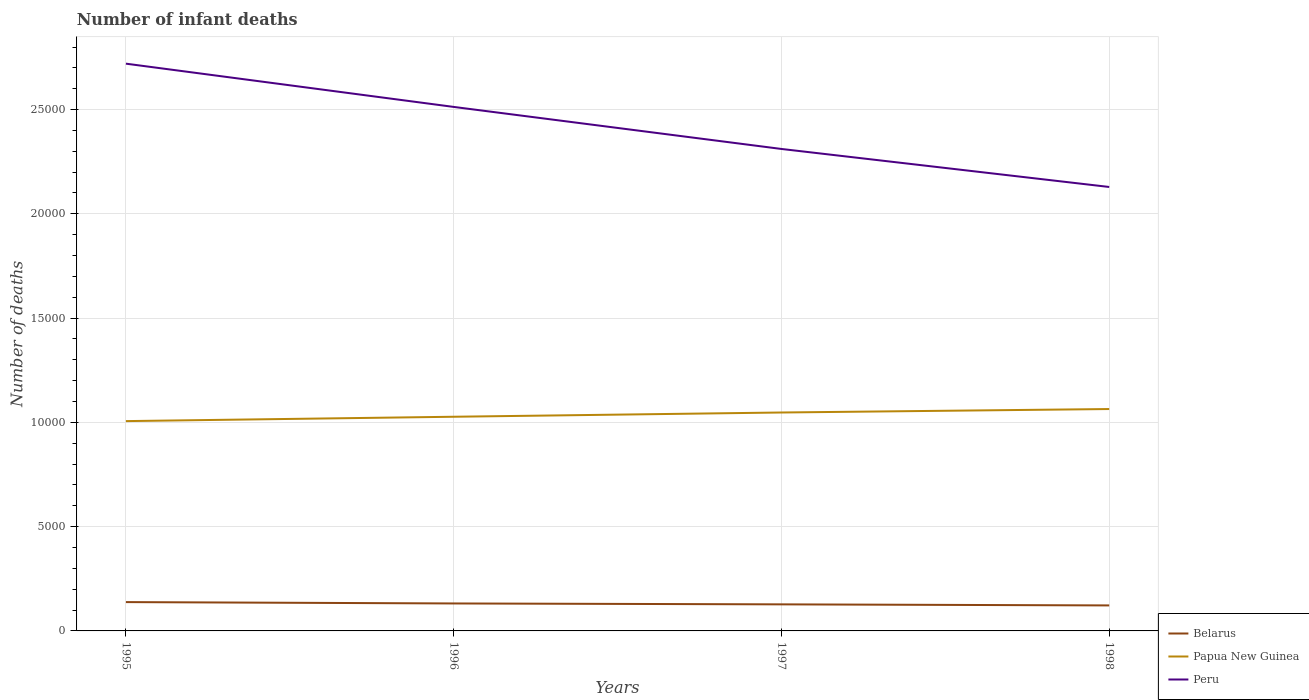How many different coloured lines are there?
Ensure brevity in your answer.  3. Across all years, what is the maximum number of infant deaths in Peru?
Provide a short and direct response. 2.13e+04. In which year was the number of infant deaths in Peru maximum?
Ensure brevity in your answer.  1998. What is the total number of infant deaths in Peru in the graph?
Make the answer very short. 4090. What is the difference between the highest and the second highest number of infant deaths in Belarus?
Your answer should be compact. 159. How many lines are there?
Keep it short and to the point. 3. Are the values on the major ticks of Y-axis written in scientific E-notation?
Your response must be concise. No. Does the graph contain any zero values?
Ensure brevity in your answer.  No. Does the graph contain grids?
Make the answer very short. Yes. Where does the legend appear in the graph?
Offer a terse response. Bottom right. How many legend labels are there?
Make the answer very short. 3. How are the legend labels stacked?
Provide a short and direct response. Vertical. What is the title of the graph?
Your answer should be compact. Number of infant deaths. What is the label or title of the Y-axis?
Your response must be concise. Number of deaths. What is the Number of deaths of Belarus in 1995?
Give a very brief answer. 1382. What is the Number of deaths of Papua New Guinea in 1995?
Offer a very short reply. 1.01e+04. What is the Number of deaths of Peru in 1995?
Provide a short and direct response. 2.72e+04. What is the Number of deaths of Belarus in 1996?
Offer a terse response. 1317. What is the Number of deaths in Papua New Guinea in 1996?
Your answer should be very brief. 1.03e+04. What is the Number of deaths of Peru in 1996?
Provide a succinct answer. 2.51e+04. What is the Number of deaths of Belarus in 1997?
Offer a very short reply. 1274. What is the Number of deaths of Papua New Guinea in 1997?
Provide a succinct answer. 1.05e+04. What is the Number of deaths of Peru in 1997?
Make the answer very short. 2.31e+04. What is the Number of deaths of Belarus in 1998?
Keep it short and to the point. 1223. What is the Number of deaths of Papua New Guinea in 1998?
Offer a terse response. 1.06e+04. What is the Number of deaths in Peru in 1998?
Your answer should be compact. 2.13e+04. Across all years, what is the maximum Number of deaths in Belarus?
Give a very brief answer. 1382. Across all years, what is the maximum Number of deaths in Papua New Guinea?
Make the answer very short. 1.06e+04. Across all years, what is the maximum Number of deaths in Peru?
Make the answer very short. 2.72e+04. Across all years, what is the minimum Number of deaths in Belarus?
Offer a terse response. 1223. Across all years, what is the minimum Number of deaths of Papua New Guinea?
Provide a succinct answer. 1.01e+04. Across all years, what is the minimum Number of deaths in Peru?
Provide a succinct answer. 2.13e+04. What is the total Number of deaths in Belarus in the graph?
Provide a succinct answer. 5196. What is the total Number of deaths in Papua New Guinea in the graph?
Your answer should be very brief. 4.14e+04. What is the total Number of deaths of Peru in the graph?
Provide a succinct answer. 9.67e+04. What is the difference between the Number of deaths in Belarus in 1995 and that in 1996?
Make the answer very short. 65. What is the difference between the Number of deaths of Papua New Guinea in 1995 and that in 1996?
Your answer should be very brief. -209. What is the difference between the Number of deaths of Peru in 1995 and that in 1996?
Ensure brevity in your answer.  2074. What is the difference between the Number of deaths of Belarus in 1995 and that in 1997?
Keep it short and to the point. 108. What is the difference between the Number of deaths of Papua New Guinea in 1995 and that in 1997?
Your answer should be compact. -413. What is the difference between the Number of deaths of Peru in 1995 and that in 1997?
Your answer should be compact. 4090. What is the difference between the Number of deaths of Belarus in 1995 and that in 1998?
Offer a terse response. 159. What is the difference between the Number of deaths of Papua New Guinea in 1995 and that in 1998?
Offer a very short reply. -579. What is the difference between the Number of deaths in Peru in 1995 and that in 1998?
Make the answer very short. 5913. What is the difference between the Number of deaths in Belarus in 1996 and that in 1997?
Keep it short and to the point. 43. What is the difference between the Number of deaths of Papua New Guinea in 1996 and that in 1997?
Offer a terse response. -204. What is the difference between the Number of deaths of Peru in 1996 and that in 1997?
Your answer should be compact. 2016. What is the difference between the Number of deaths of Belarus in 1996 and that in 1998?
Keep it short and to the point. 94. What is the difference between the Number of deaths of Papua New Guinea in 1996 and that in 1998?
Give a very brief answer. -370. What is the difference between the Number of deaths in Peru in 1996 and that in 1998?
Offer a terse response. 3839. What is the difference between the Number of deaths of Belarus in 1997 and that in 1998?
Make the answer very short. 51. What is the difference between the Number of deaths in Papua New Guinea in 1997 and that in 1998?
Offer a very short reply. -166. What is the difference between the Number of deaths in Peru in 1997 and that in 1998?
Ensure brevity in your answer.  1823. What is the difference between the Number of deaths in Belarus in 1995 and the Number of deaths in Papua New Guinea in 1996?
Ensure brevity in your answer.  -8888. What is the difference between the Number of deaths of Belarus in 1995 and the Number of deaths of Peru in 1996?
Keep it short and to the point. -2.37e+04. What is the difference between the Number of deaths in Papua New Guinea in 1995 and the Number of deaths in Peru in 1996?
Make the answer very short. -1.51e+04. What is the difference between the Number of deaths of Belarus in 1995 and the Number of deaths of Papua New Guinea in 1997?
Ensure brevity in your answer.  -9092. What is the difference between the Number of deaths in Belarus in 1995 and the Number of deaths in Peru in 1997?
Provide a short and direct response. -2.17e+04. What is the difference between the Number of deaths of Papua New Guinea in 1995 and the Number of deaths of Peru in 1997?
Give a very brief answer. -1.30e+04. What is the difference between the Number of deaths of Belarus in 1995 and the Number of deaths of Papua New Guinea in 1998?
Give a very brief answer. -9258. What is the difference between the Number of deaths of Belarus in 1995 and the Number of deaths of Peru in 1998?
Provide a succinct answer. -1.99e+04. What is the difference between the Number of deaths of Papua New Guinea in 1995 and the Number of deaths of Peru in 1998?
Give a very brief answer. -1.12e+04. What is the difference between the Number of deaths of Belarus in 1996 and the Number of deaths of Papua New Guinea in 1997?
Ensure brevity in your answer.  -9157. What is the difference between the Number of deaths in Belarus in 1996 and the Number of deaths in Peru in 1997?
Keep it short and to the point. -2.18e+04. What is the difference between the Number of deaths in Papua New Guinea in 1996 and the Number of deaths in Peru in 1997?
Make the answer very short. -1.28e+04. What is the difference between the Number of deaths of Belarus in 1996 and the Number of deaths of Papua New Guinea in 1998?
Your response must be concise. -9323. What is the difference between the Number of deaths of Belarus in 1996 and the Number of deaths of Peru in 1998?
Offer a very short reply. -2.00e+04. What is the difference between the Number of deaths of Papua New Guinea in 1996 and the Number of deaths of Peru in 1998?
Keep it short and to the point. -1.10e+04. What is the difference between the Number of deaths of Belarus in 1997 and the Number of deaths of Papua New Guinea in 1998?
Keep it short and to the point. -9366. What is the difference between the Number of deaths in Belarus in 1997 and the Number of deaths in Peru in 1998?
Keep it short and to the point. -2.00e+04. What is the difference between the Number of deaths in Papua New Guinea in 1997 and the Number of deaths in Peru in 1998?
Give a very brief answer. -1.08e+04. What is the average Number of deaths in Belarus per year?
Keep it short and to the point. 1299. What is the average Number of deaths in Papua New Guinea per year?
Give a very brief answer. 1.04e+04. What is the average Number of deaths in Peru per year?
Keep it short and to the point. 2.42e+04. In the year 1995, what is the difference between the Number of deaths of Belarus and Number of deaths of Papua New Guinea?
Your answer should be very brief. -8679. In the year 1995, what is the difference between the Number of deaths in Belarus and Number of deaths in Peru?
Provide a succinct answer. -2.58e+04. In the year 1995, what is the difference between the Number of deaths in Papua New Guinea and Number of deaths in Peru?
Keep it short and to the point. -1.71e+04. In the year 1996, what is the difference between the Number of deaths of Belarus and Number of deaths of Papua New Guinea?
Keep it short and to the point. -8953. In the year 1996, what is the difference between the Number of deaths in Belarus and Number of deaths in Peru?
Your response must be concise. -2.38e+04. In the year 1996, what is the difference between the Number of deaths of Papua New Guinea and Number of deaths of Peru?
Make the answer very short. -1.49e+04. In the year 1997, what is the difference between the Number of deaths of Belarus and Number of deaths of Papua New Guinea?
Make the answer very short. -9200. In the year 1997, what is the difference between the Number of deaths in Belarus and Number of deaths in Peru?
Your answer should be compact. -2.18e+04. In the year 1997, what is the difference between the Number of deaths of Papua New Guinea and Number of deaths of Peru?
Make the answer very short. -1.26e+04. In the year 1998, what is the difference between the Number of deaths of Belarus and Number of deaths of Papua New Guinea?
Your answer should be compact. -9417. In the year 1998, what is the difference between the Number of deaths in Belarus and Number of deaths in Peru?
Offer a terse response. -2.01e+04. In the year 1998, what is the difference between the Number of deaths in Papua New Guinea and Number of deaths in Peru?
Your answer should be very brief. -1.06e+04. What is the ratio of the Number of deaths in Belarus in 1995 to that in 1996?
Your answer should be compact. 1.05. What is the ratio of the Number of deaths in Papua New Guinea in 1995 to that in 1996?
Offer a terse response. 0.98. What is the ratio of the Number of deaths of Peru in 1995 to that in 1996?
Give a very brief answer. 1.08. What is the ratio of the Number of deaths in Belarus in 1995 to that in 1997?
Provide a succinct answer. 1.08. What is the ratio of the Number of deaths of Papua New Guinea in 1995 to that in 1997?
Your answer should be very brief. 0.96. What is the ratio of the Number of deaths of Peru in 1995 to that in 1997?
Provide a succinct answer. 1.18. What is the ratio of the Number of deaths of Belarus in 1995 to that in 1998?
Offer a very short reply. 1.13. What is the ratio of the Number of deaths of Papua New Guinea in 1995 to that in 1998?
Provide a succinct answer. 0.95. What is the ratio of the Number of deaths in Peru in 1995 to that in 1998?
Make the answer very short. 1.28. What is the ratio of the Number of deaths of Belarus in 1996 to that in 1997?
Provide a short and direct response. 1.03. What is the ratio of the Number of deaths of Papua New Guinea in 1996 to that in 1997?
Offer a very short reply. 0.98. What is the ratio of the Number of deaths of Peru in 1996 to that in 1997?
Offer a terse response. 1.09. What is the ratio of the Number of deaths in Belarus in 1996 to that in 1998?
Provide a short and direct response. 1.08. What is the ratio of the Number of deaths of Papua New Guinea in 1996 to that in 1998?
Your response must be concise. 0.97. What is the ratio of the Number of deaths in Peru in 1996 to that in 1998?
Provide a short and direct response. 1.18. What is the ratio of the Number of deaths in Belarus in 1997 to that in 1998?
Keep it short and to the point. 1.04. What is the ratio of the Number of deaths in Papua New Guinea in 1997 to that in 1998?
Provide a succinct answer. 0.98. What is the ratio of the Number of deaths of Peru in 1997 to that in 1998?
Make the answer very short. 1.09. What is the difference between the highest and the second highest Number of deaths of Papua New Guinea?
Keep it short and to the point. 166. What is the difference between the highest and the second highest Number of deaths in Peru?
Your response must be concise. 2074. What is the difference between the highest and the lowest Number of deaths of Belarus?
Offer a terse response. 159. What is the difference between the highest and the lowest Number of deaths in Papua New Guinea?
Make the answer very short. 579. What is the difference between the highest and the lowest Number of deaths in Peru?
Your answer should be very brief. 5913. 